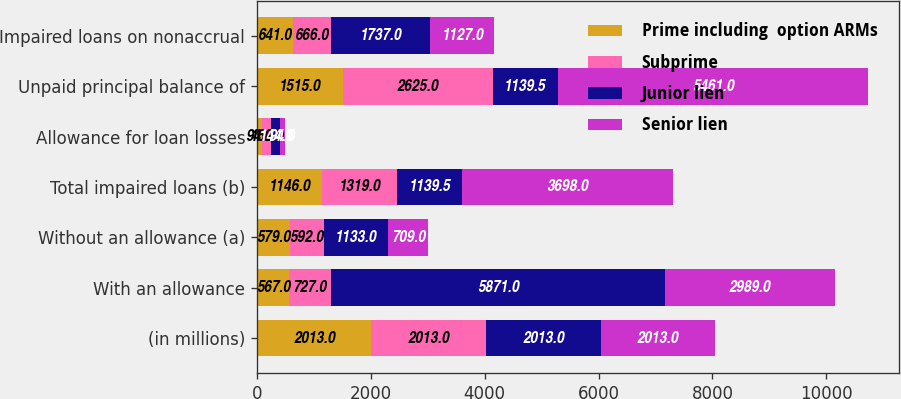Convert chart to OTSL. <chart><loc_0><loc_0><loc_500><loc_500><stacked_bar_chart><ecel><fcel>(in millions)<fcel>With an allowance<fcel>Without an allowance (a)<fcel>Total impaired loans (b)<fcel>Allowance for loan losses<fcel>Unpaid principal balance of<fcel>Impaired loans on nonaccrual<nl><fcel>Prime including  option ARMs<fcel>2013<fcel>567<fcel>579<fcel>1146<fcel>94<fcel>1515<fcel>641<nl><fcel>Subprime<fcel>2013<fcel>727<fcel>592<fcel>1319<fcel>162<fcel>2625<fcel>666<nl><fcel>Junior lien<fcel>2013<fcel>5871<fcel>1133<fcel>1139.5<fcel>144<fcel>1139.5<fcel>1737<nl><fcel>Senior lien<fcel>2013<fcel>2989<fcel>709<fcel>3698<fcel>94<fcel>5461<fcel>1127<nl></chart> 